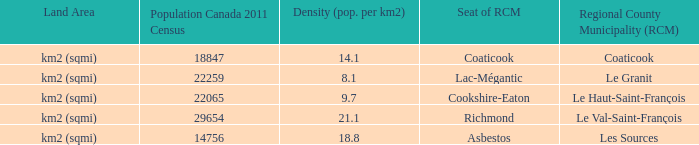What is the land area for the RCM that has a population of 18847? Km2 (sqmi). 